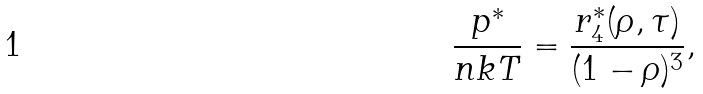<formula> <loc_0><loc_0><loc_500><loc_500>\frac { p ^ { * } } { n k T } = \frac { r _ { 4 } ^ { * } ( \rho , \tau ) } { ( 1 - \rho ) ^ { 3 } } ,</formula> 